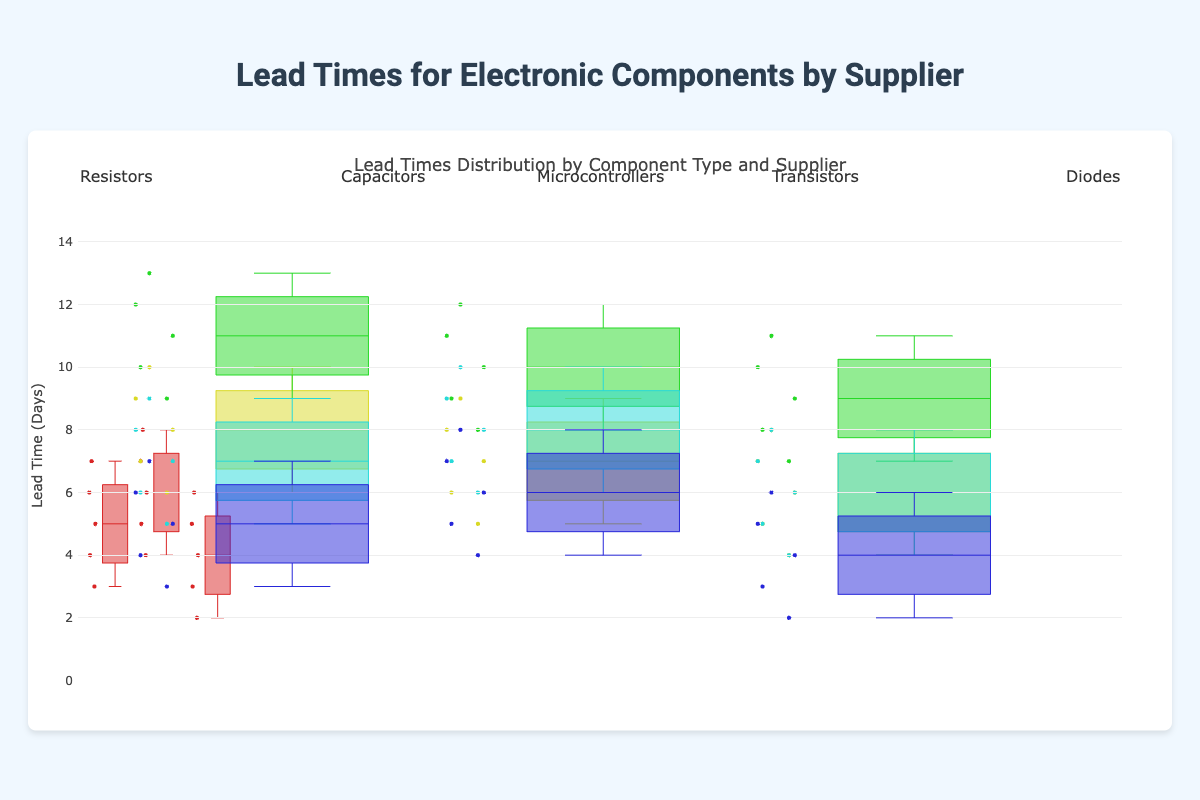What is the title of the figure? The title is displayed prominently at the top of the figure. It can be read directly from the visual information provided.
Answer: Lead Times for Electronic Components by Supplier What is the range of the y-axis? The y-axis range can be seen on the left side of the figure. It indicates the range of values for the lead times.
Answer: 0 to 15 Which supplier has the shortest median lead time for resistors? Look at the median line within the box plot for each supplier. The median is the line inside the box.
Answer: Murata What is the upper quartile for Texas Instruments microcontrollers' lead times? The upper quartile is the top edge of the box, which represents the 75th percentile of the data for Texas Instruments microcontrollers.
Answer: 12 days Compare the median lead times for TDK capacitors and NXP transistors. Which one is higher? Find the median lines (the lines inside the boxes) for TDK capacitors and NXP transistors and compare their positions on the y-axis.
Answer: TDK capacitors Which component type shows the highest variability in lead times? Variability can be interpreted by the height of the boxes and the spread of the whiskers. The taller the box and the farther the whiskers, the higher the variability.
Answer: Microcontrollers What is the interquartile range (IQR) for Rohm diodes' lead times? The IQR is the difference between the upper quartile (75th percentile) and the lower quartile (25th percentile). For Rohm diodes, subtract the value at the bottom of the box from the value at the top of the box.
Answer: 3 days Which supplier has the most consistent lead times for capacitors? Consistency can be determined by looking at which box plot has the smallest spread (height of the box and whiskers).
Answer: Samsung What is the lead time for the highest observed value for STMicroelectronics microcontrollers? The highest observed value will be marked by the topmost point (above the top whisker) for STMicroelectronics microcontrollers.
Answer: 11 days Among diodes, which supplier has the smallest maximum lead time and what is it? The maximum lead time is indicated by the top whisker or the highest point. Compare the top whiskers or points for each diode supplier.
Answer: Vishay, 6 days 